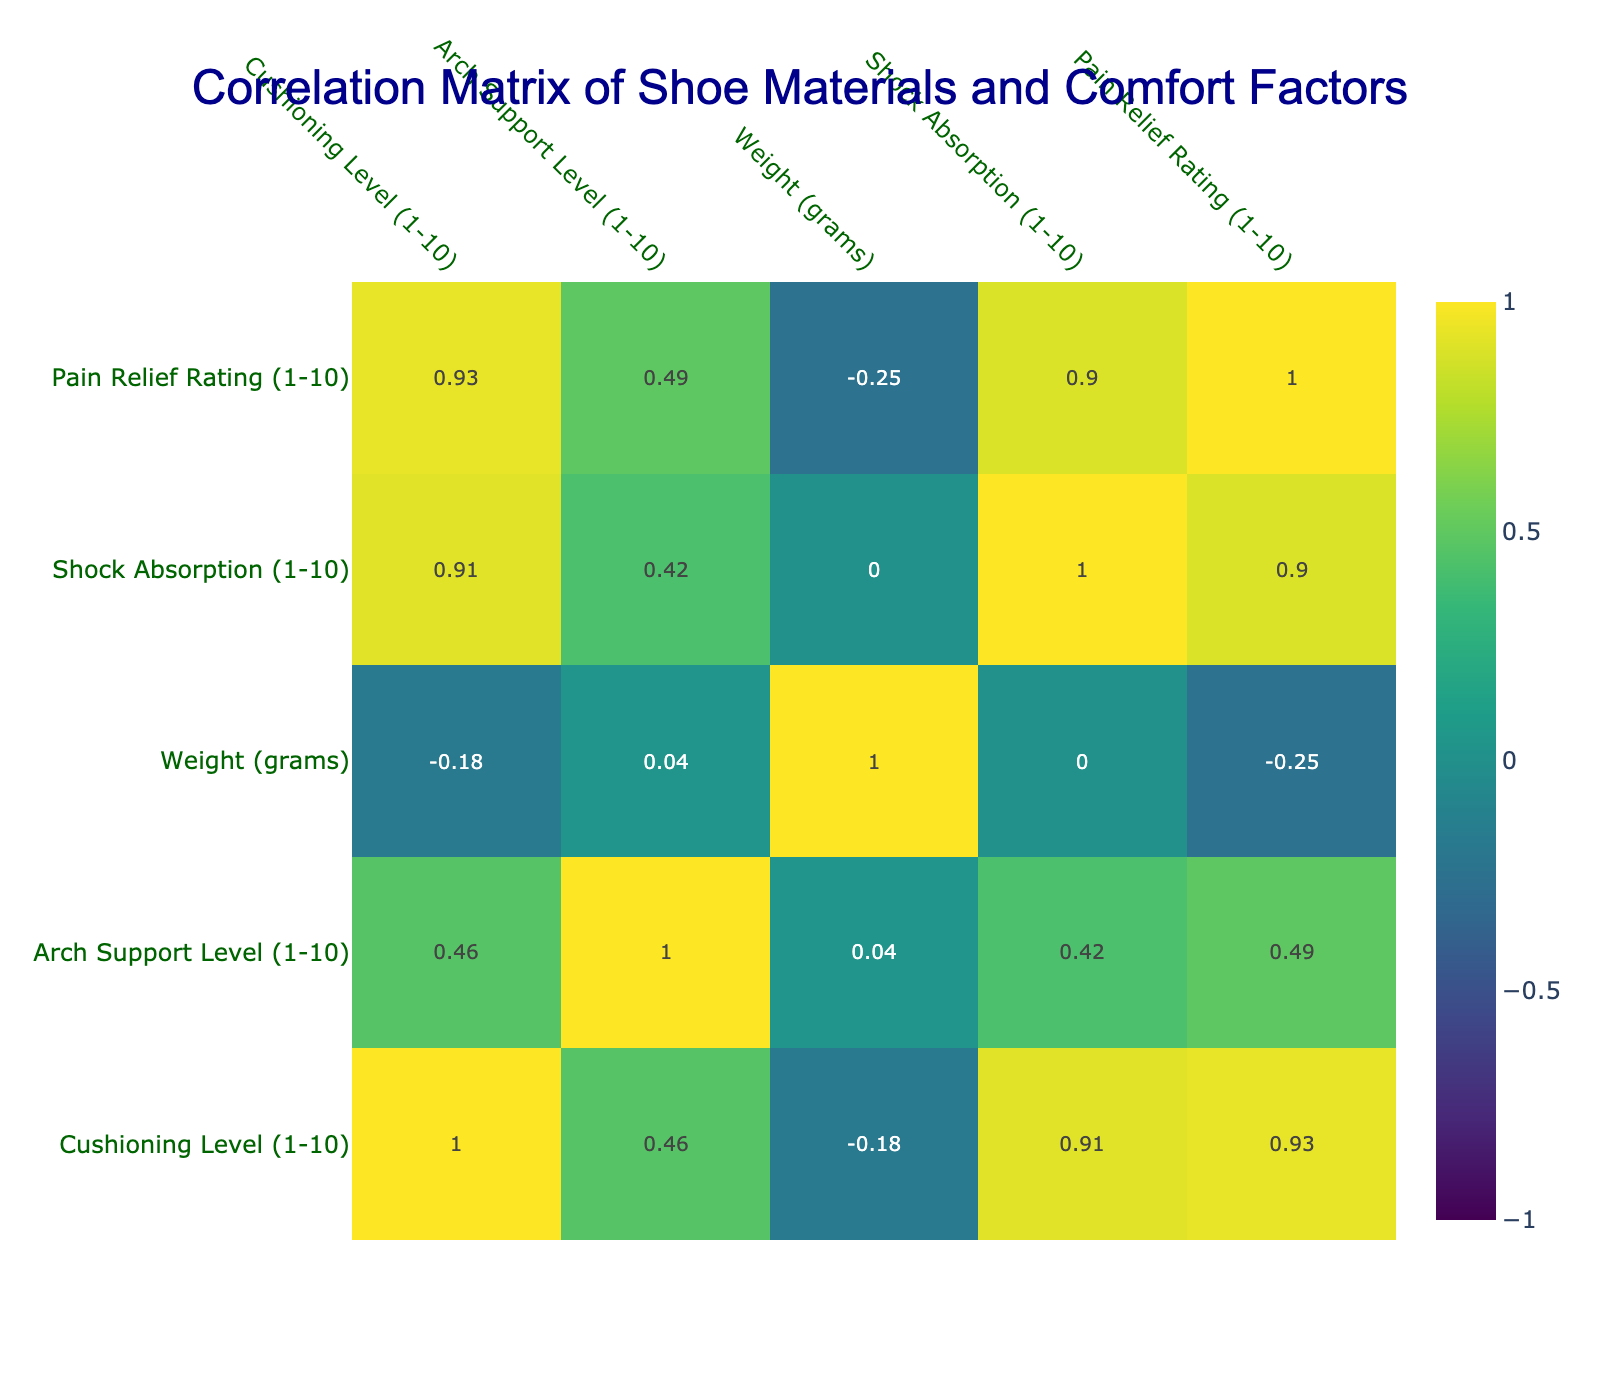What is the cushioning level of Memory Foam? The table shows that Memory Foam has a cushioning level of 10.
Answer: 10 What material has the highest pain relief rating? By checking the Pain Relief Rating column, Gel and Memory Foam both have the highest rating of 9.
Answer: 9 Is there a material that has both high shock absorption (10) and high cushioning level (9 or above)? Yes, Memory Foam has a shock absorption level of 10 and a cushioning level of 10.
Answer: Yes Which material has the lowest arch support level? The table indicates that Canvas has the lowest arch support level, with a score of 3.
Answer: 3 What is the average weight of shoes made from EVA Foam, Gel, and Memory Foam? We first sum the weights of these materials: 300 (EVA Foam) + 350 (Gel) + 280 (Memory Foam) = 930 grams. There are 3 materials, so the average weight is 930 / 3 = 310 grams.
Answer: 310 grams Is the cushioning level of Leather greater than that of Suede? The cushioning level of Leather is 5 and that of Suede is also 5, so they are equal.
Answer: No Which material has the best combination of cushioning level and shock absorption? Looking at the table, Memory Foam has a cushioning level of 10 and shock absorption of 10, giving it the best combination.
Answer: Memory Foam What is the difference in pain relief rating between EVA Foam and Polyurethane? EVA Foam has a pain relief rating of 8, and Polyurethane has a rating of 6. The difference is 8 - 6 = 2.
Answer: 2 Given the cushioning levels, which material would you recommend for maximum comfort based on the table? Memory Foam has the highest cushioning level (10), indicating it is likely the most comfortable option based on the data.
Answer: Memory Foam 